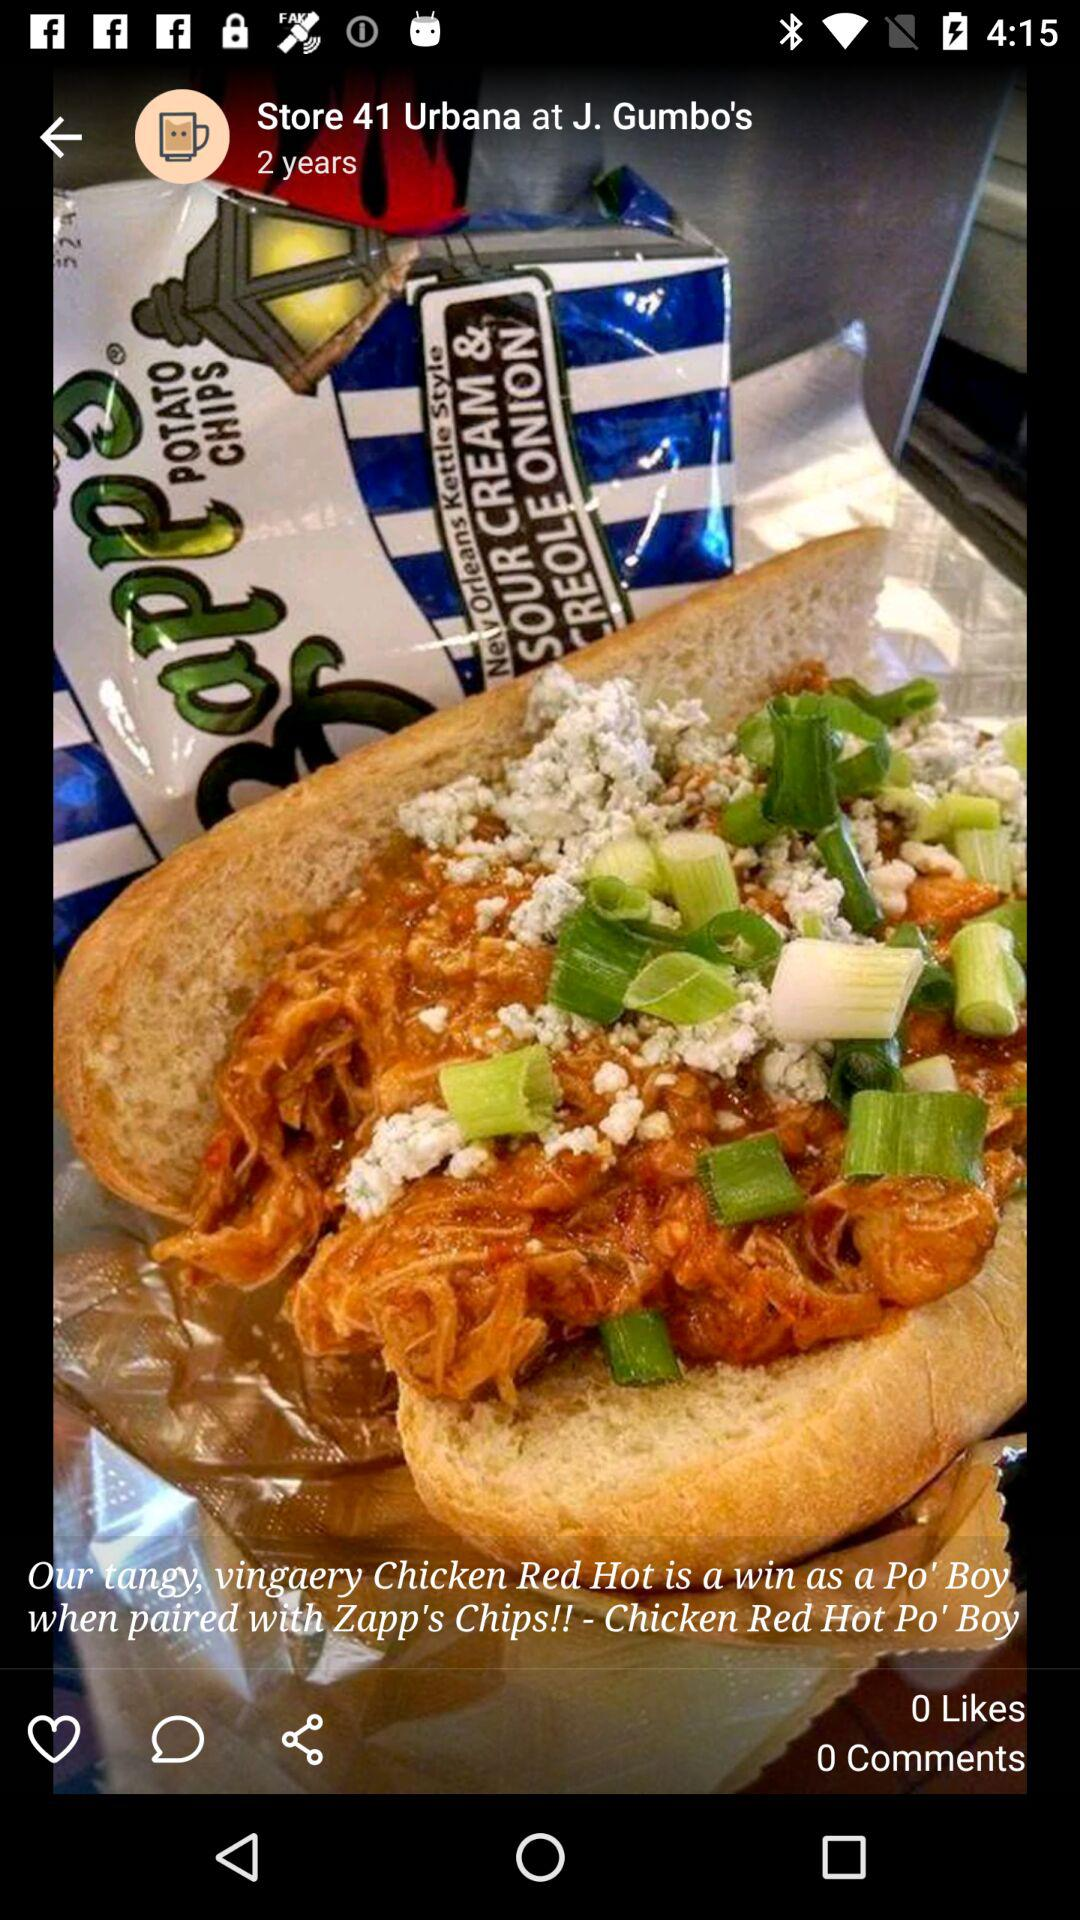What is the location of the store?
When the provided information is insufficient, respond with <no answer>. <no answer> 